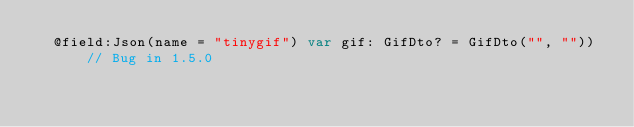<code> <loc_0><loc_0><loc_500><loc_500><_Kotlin_>  @field:Json(name = "tinygif") var gif: GifDto? = GifDto("", "")) // Bug in 1.5.0
</code> 